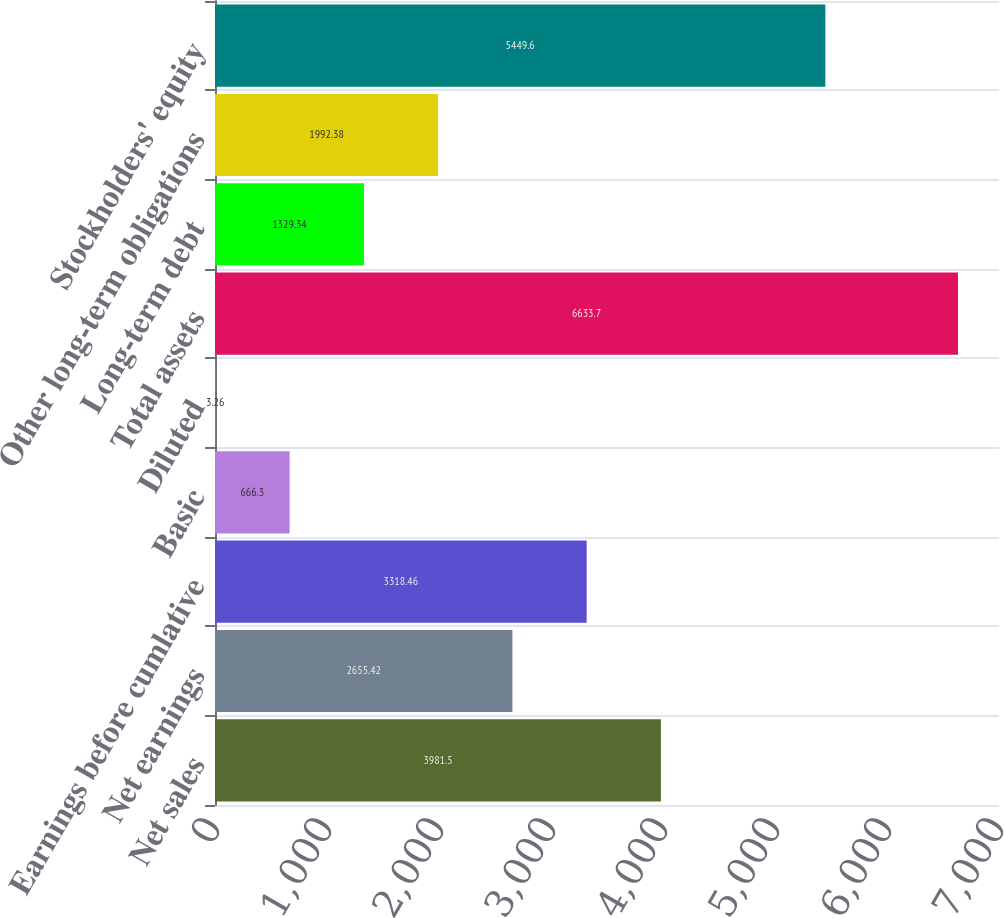Convert chart. <chart><loc_0><loc_0><loc_500><loc_500><bar_chart><fcel>Net sales<fcel>Net earnings<fcel>Earnings before cumlative<fcel>Basic<fcel>Diluted<fcel>Total assets<fcel>Long-term debt<fcel>Other long-term obligations<fcel>Stockholders' equity<nl><fcel>3981.5<fcel>2655.42<fcel>3318.46<fcel>666.3<fcel>3.26<fcel>6633.7<fcel>1329.34<fcel>1992.38<fcel>5449.6<nl></chart> 